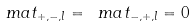<formula> <loc_0><loc_0><loc_500><loc_500>\ m a t _ { + , - , l } = \ m a t _ { - , + , l } = 0</formula> 